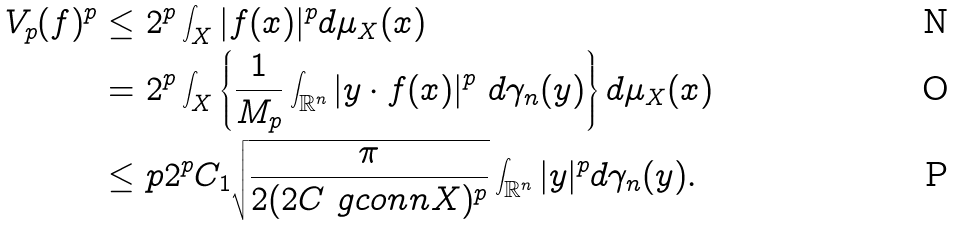<formula> <loc_0><loc_0><loc_500><loc_500>V _ { p } ( f ) ^ { p } \leq \ & 2 ^ { p } \int _ { X } | f ( x ) | ^ { p } d \mu _ { X } ( x ) \\ = \ & 2 ^ { p } \int _ { X } \left \{ \frac { 1 } { M _ { p } } \int _ { \mathbb { R } ^ { n } } | y \cdot f ( x ) | ^ { p } \ d \gamma _ { n } ( y ) \right \} d \mu _ { X } ( x ) \\ \leq \ & p 2 ^ { p } C _ { 1 } \sqrt { \frac { \pi } { 2 ( 2 C \ g c o n n { X } ) ^ { p } } } \int _ { \mathbb { R } ^ { n } } | y | ^ { p } d \gamma _ { n } ( y ) .</formula> 